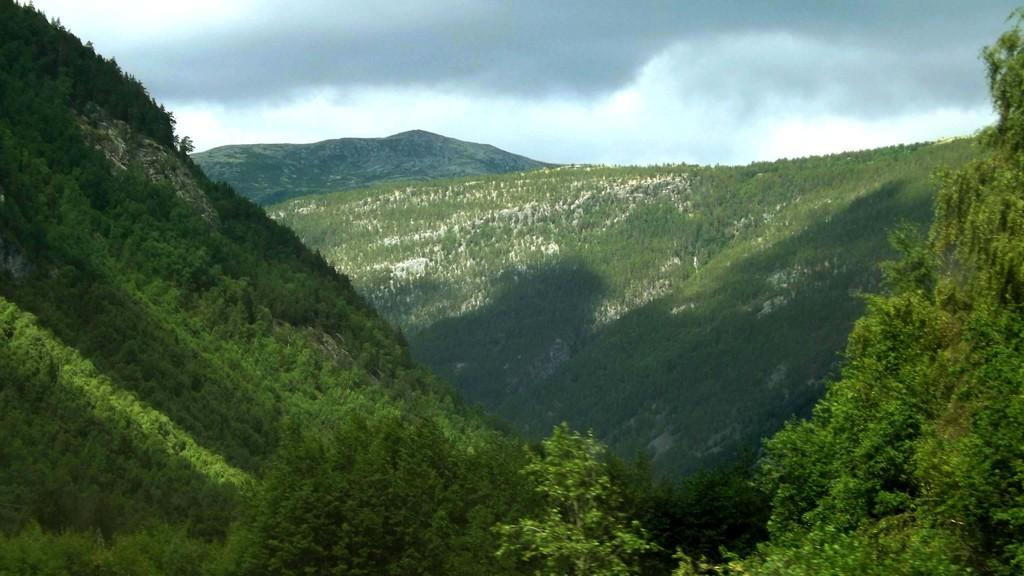What type of vegetation is at the bottom of the image? There are trees at the bottom of the image. What geographical features can be seen in the background of the image? There are mountains in the background of the image. What can be seen in the sky in the image? There are clouds in the sky. What type of band is playing in the image? There is no band present in the image. How does the wire affect the appearance of the image? There is no wire present in the image. 